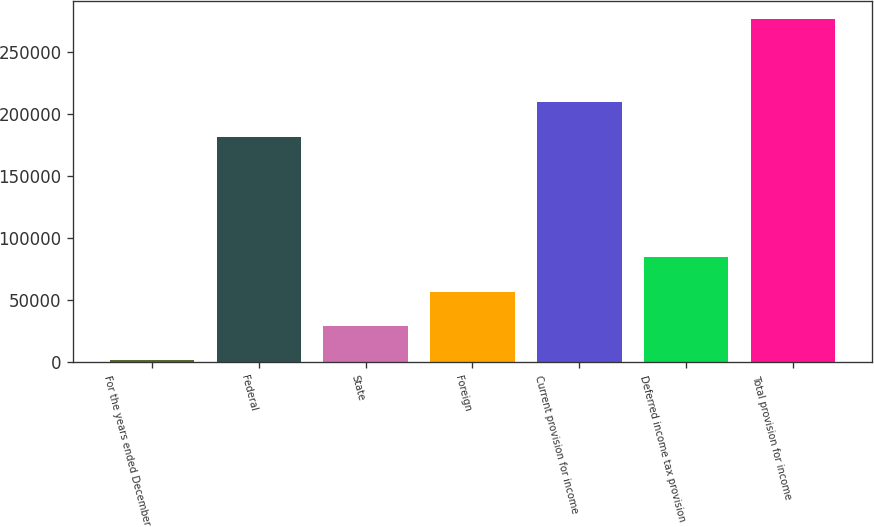Convert chart. <chart><loc_0><loc_0><loc_500><loc_500><bar_chart><fcel>For the years ended December<fcel>Federal<fcel>State<fcel>Foreign<fcel>Current provision for income<fcel>Deferred income tax provision<fcel>Total provision for income<nl><fcel>2005<fcel>181947<fcel>29513.5<fcel>57022<fcel>209456<fcel>84530.5<fcel>277090<nl></chart> 